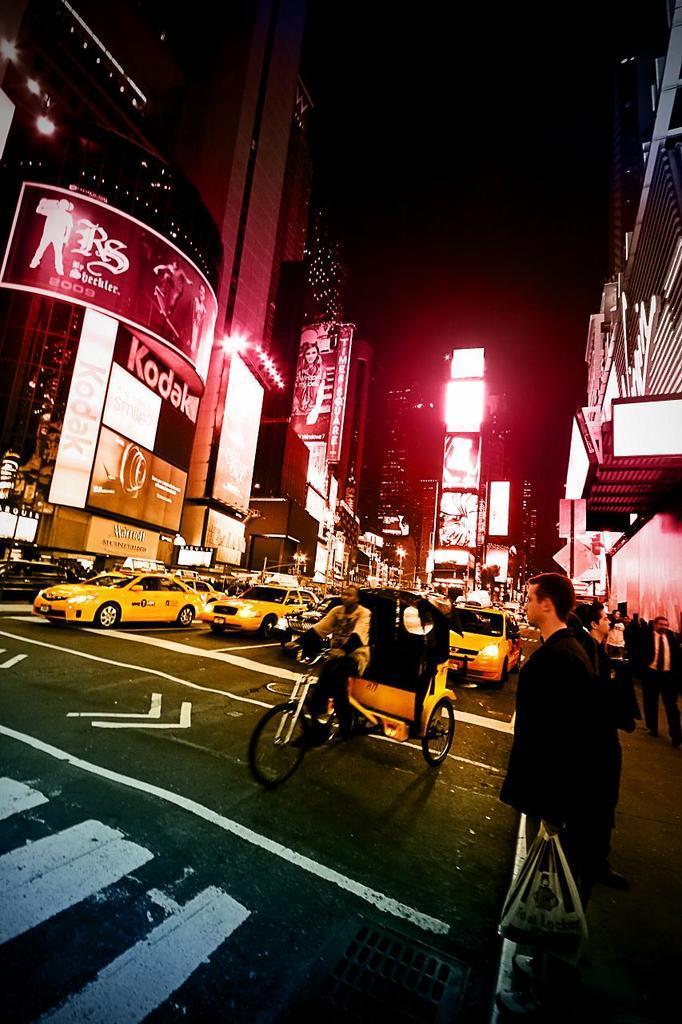Describe this image in one or two sentences. In this image a person is standing and he is holding a carry bag,A group of cars are moving on the road and large buildings we can see in the image. 